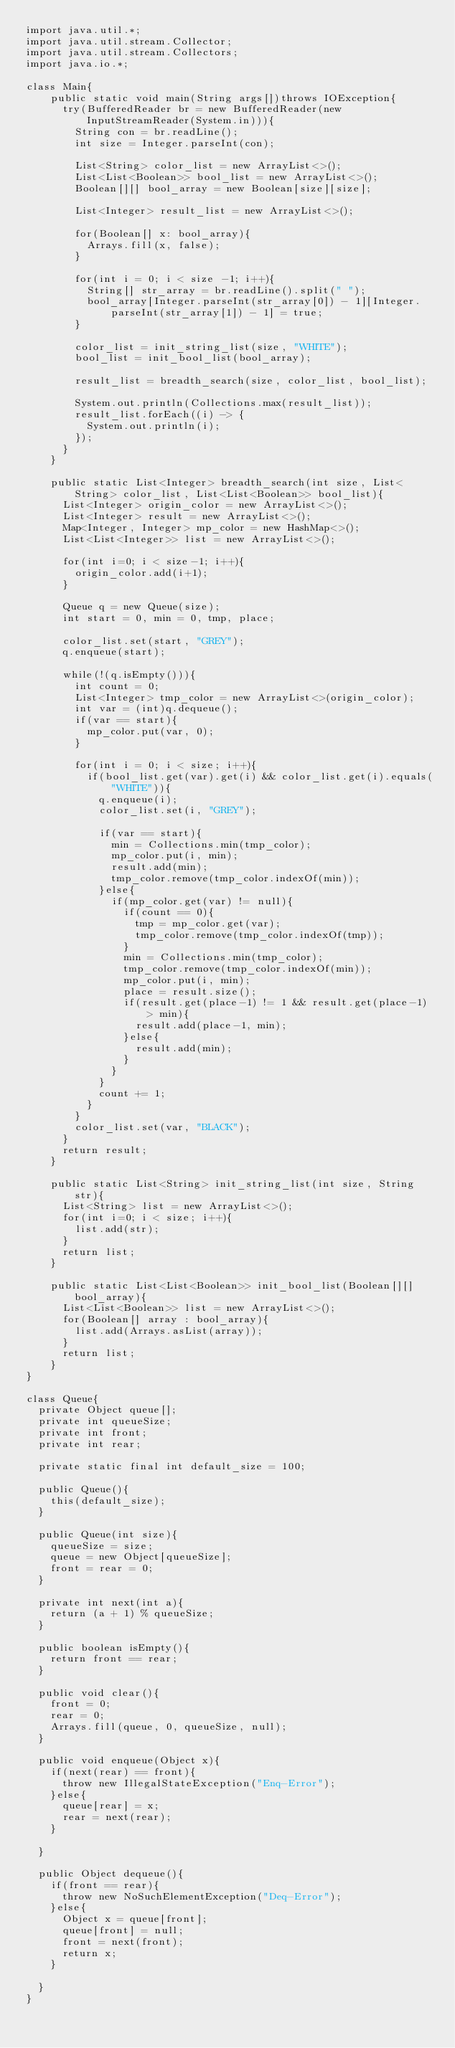Convert code to text. <code><loc_0><loc_0><loc_500><loc_500><_Java_>import java.util.*;
import java.util.stream.Collector;
import java.util.stream.Collectors;
import java.io.*;

class Main{
    public static void main(String args[])throws IOException{
      try(BufferedReader br = new BufferedReader(new InputStreamReader(System.in))){
        String con = br.readLine();
        int size = Integer.parseInt(con);

        List<String> color_list = new ArrayList<>();
        List<List<Boolean>> bool_list = new ArrayList<>();
        Boolean[][] bool_array = new Boolean[size][size];

        List<Integer> result_list = new ArrayList<>();

        for(Boolean[] x: bool_array){
          Arrays.fill(x, false);
        }

        for(int i = 0; i < size -1; i++){
          String[] str_array = br.readLine().split(" ");
          bool_array[Integer.parseInt(str_array[0]) - 1][Integer.parseInt(str_array[1]) - 1] = true;
        }

        color_list = init_string_list(size, "WHITE");
        bool_list = init_bool_list(bool_array);

        result_list = breadth_search(size, color_list, bool_list);
        
        System.out.println(Collections.max(result_list));
        result_list.forEach((i) -> {
          System.out.println(i);
        });
      }
    }

    public static List<Integer> breadth_search(int size, List<String> color_list, List<List<Boolean>> bool_list){
      List<Integer> origin_color = new ArrayList<>();
      List<Integer> result = new ArrayList<>();
      Map<Integer, Integer> mp_color = new HashMap<>();
      List<List<Integer>> list = new ArrayList<>();

      for(int i=0; i < size-1; i++){
        origin_color.add(i+1);
      }

      Queue q = new Queue(size);
      int start = 0, min = 0, tmp, place;

      color_list.set(start, "GREY");
      q.enqueue(start);

      while(!(q.isEmpty())){
        int count = 0;
        List<Integer> tmp_color = new ArrayList<>(origin_color);
        int var = (int)q.dequeue();
        if(var == start){
          mp_color.put(var, 0);
        }

        for(int i = 0; i < size; i++){
          if(bool_list.get(var).get(i) && color_list.get(i).equals("WHITE")){  
            q.enqueue(i);
            color_list.set(i, "GREY");
            
            if(var == start){
              min = Collections.min(tmp_color);
              mp_color.put(i, min);
              result.add(min);
              tmp_color.remove(tmp_color.indexOf(min));
            }else{
              if(mp_color.get(var) != null){
                if(count == 0){
                  tmp = mp_color.get(var);
                  tmp_color.remove(tmp_color.indexOf(tmp));
                }
                min = Collections.min(tmp_color);
                tmp_color.remove(tmp_color.indexOf(min));
                mp_color.put(i, min);
                place = result.size();
                if(result.get(place-1) != 1 && result.get(place-1) > min){
                  result.add(place-1, min);
                }else{
                  result.add(min);
                }
              }
            }
            count += 1;
          }
        }
        color_list.set(var, "BLACK");
      }
      return result;
    }
    
    public static List<String> init_string_list(int size, String str){
      List<String> list = new ArrayList<>();
      for(int i=0; i < size; i++){
        list.add(str);
      }
      return list;
    }

    public static List<List<Boolean>> init_bool_list(Boolean[][] bool_array){
      List<List<Boolean>> list = new ArrayList<>();
      for(Boolean[] array : bool_array){
        list.add(Arrays.asList(array));
      }
      return list;
    }
}

class Queue{
  private Object queue[];
  private int queueSize;
  private int front;
  private int rear;

  private static final int default_size = 100;

  public Queue(){
    this(default_size);
  }

  public Queue(int size){
    queueSize = size;
    queue = new Object[queueSize];
    front = rear = 0;
  }

  private int next(int a){
    return (a + 1) % queueSize;
  }

  public boolean isEmpty(){
    return front == rear;
  }

  public void clear(){
    front = 0;
    rear = 0;
    Arrays.fill(queue, 0, queueSize, null);
  }

  public void enqueue(Object x){
    if(next(rear) == front){
      throw new IllegalStateException("Enq-Error");
    }else{
      queue[rear] = x;
      rear = next(rear);
    }

  }

  public Object dequeue(){
    if(front == rear){
      throw new NoSuchElementException("Deq-Error");
    }else{
      Object x = queue[front];
      queue[front] = null;
      front = next(front);
      return x;
    }

  }
}</code> 